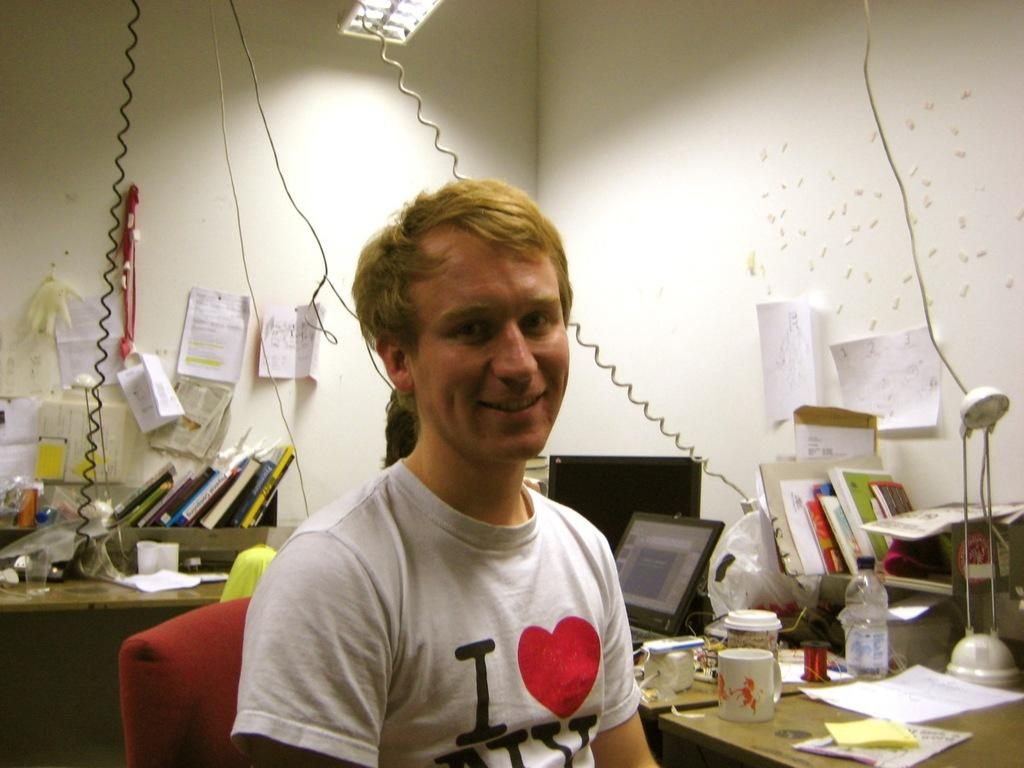<image>
Write a terse but informative summary of the picture. "I love NY" is printed on the front of this gentleman's t shirt. 